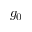<formula> <loc_0><loc_0><loc_500><loc_500>g _ { 0 }</formula> 